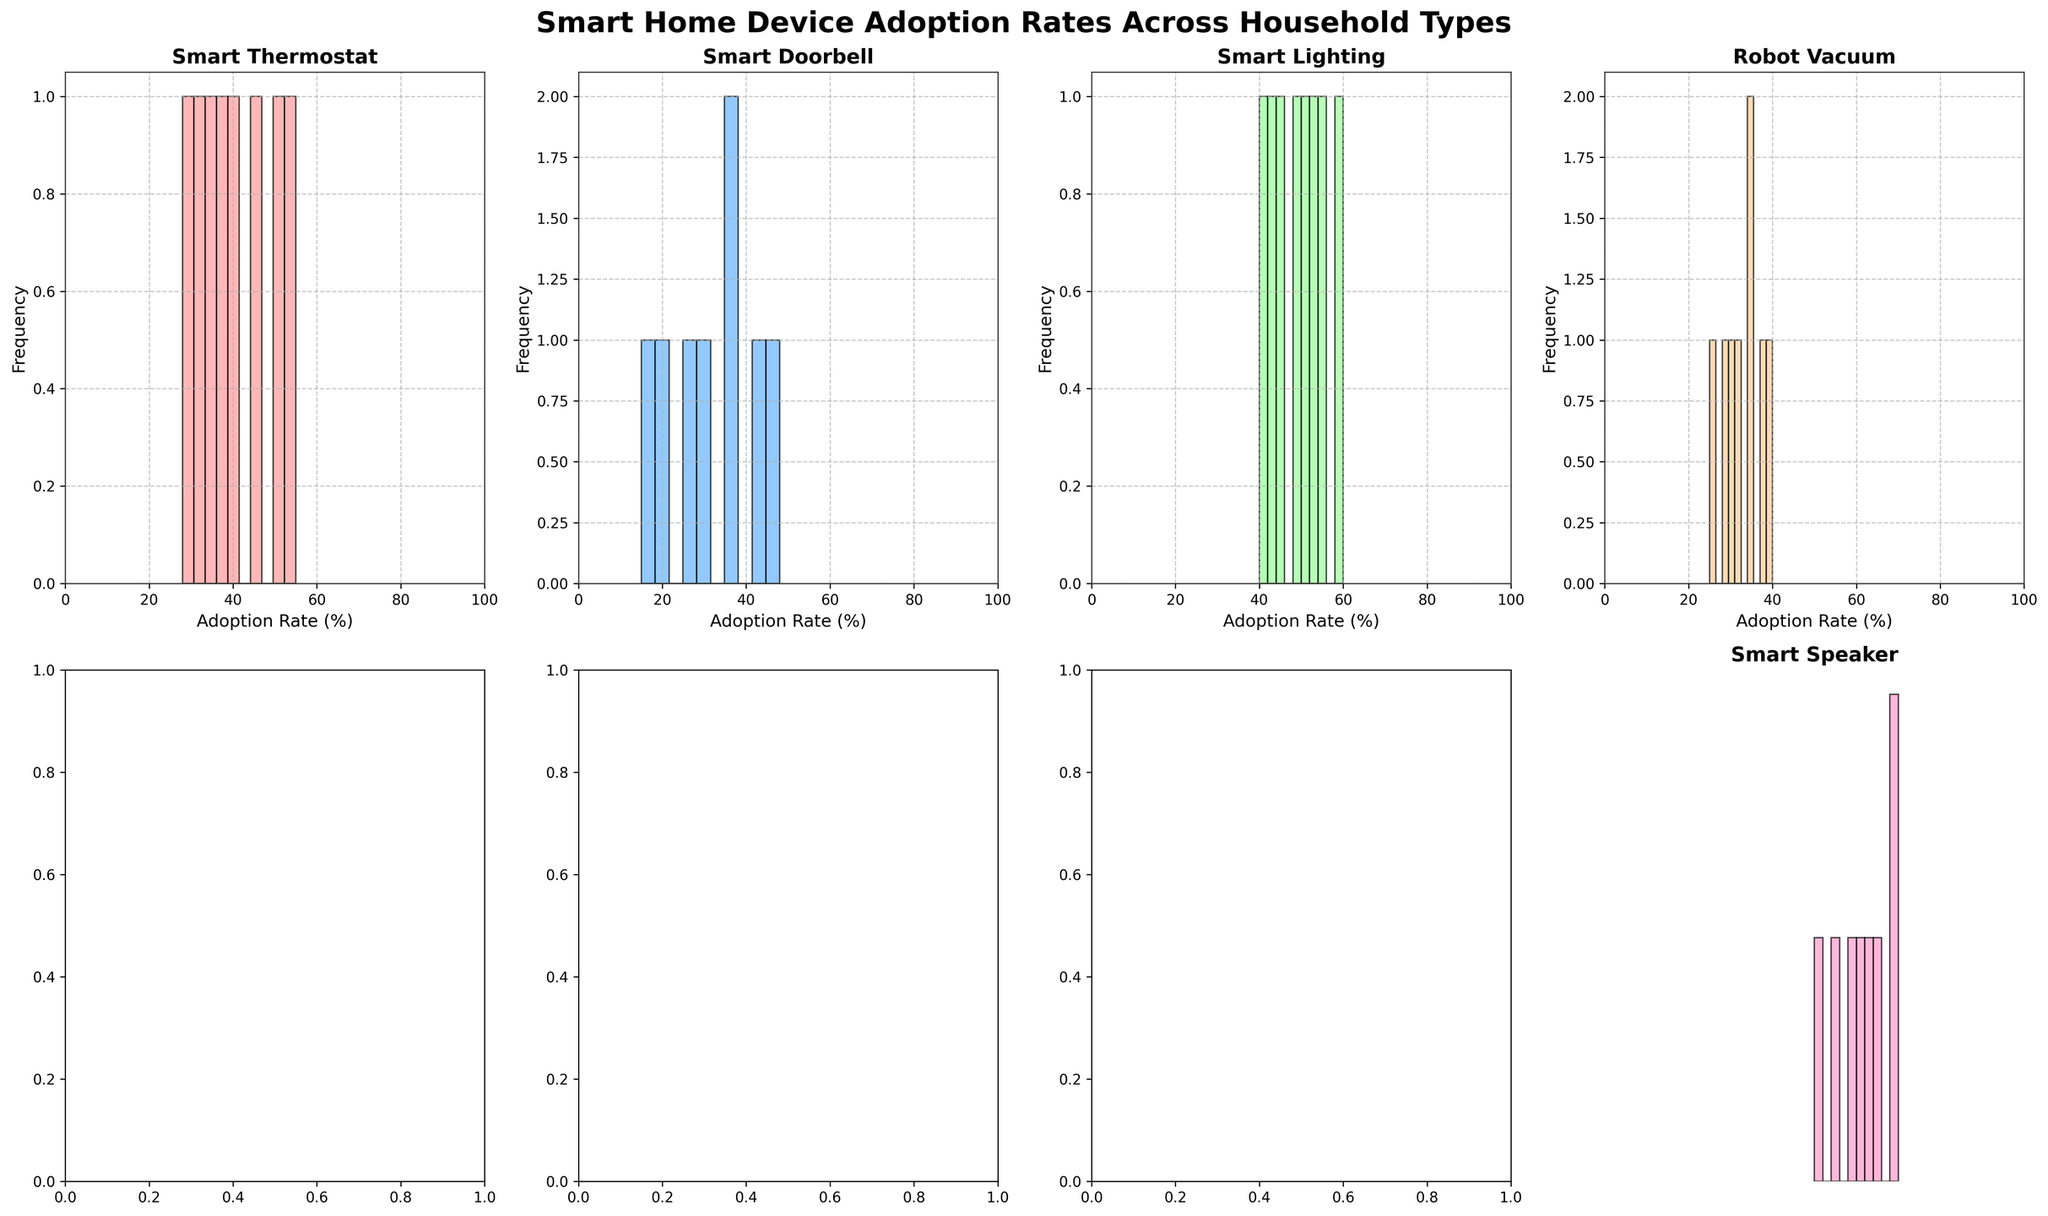What is the title of the plot? Look at the top of the figure where the title is usually displayed.
Answer: Smart Home Device Adoption Rates Across Household Types Which smart home device has the highest adoption rate in Multi-Generational Home? Locate the subplot for each device and identify the highest bar for Multi-Generational Home.
Answer: Smart Speaker Which household type has the lowest adoption rate for Smart Doorbells? Look at the Smart Doorbell subplot and find the shortest bar corresponding to a household type.
Answer: Studio Apartment What is the average adoption rate of Smart Thermostats across all household types? Add the adoption rates of Smart Thermostats for all household types and divide by the number of household types.
Answer: 40.375 Compare the adoption rates of Smart Lighting and Robot Vacuum in Vacation Homes. Which device has a higher adoption rate? Look at the subplots for Smart Lighting and Robot Vacuum and compare the heights of the bars for Vacation Home.
Answer: Smart Lighting Among the household types, which has the highest overall adoption rate for any smart device? Look across all subplots and find the highest single adoption rate among all household types.
Answer: Multi-Generational Home and Vacation Home (Smart Speaker, 70%) How many household types have a higher adoption rate for Smart Thermostats than for Robot Vacuums? Count the number of bars in the Smart Thermostat subplot that are taller than the corresponding bars in the Robot Vacuum subplot.
Answer: 4 What is the range of adoption rates for Smart Doorbells? Subtract the lowest adoption rate from the highest adoption rate for Smart Doorbells.
Answer: 48 - 15 = 33 Which device generally has the most varied adoption rates among different household types? Compare the spread of the bars in all subplots to see which device shows the most variation.
Answer: Smart Thermostat 